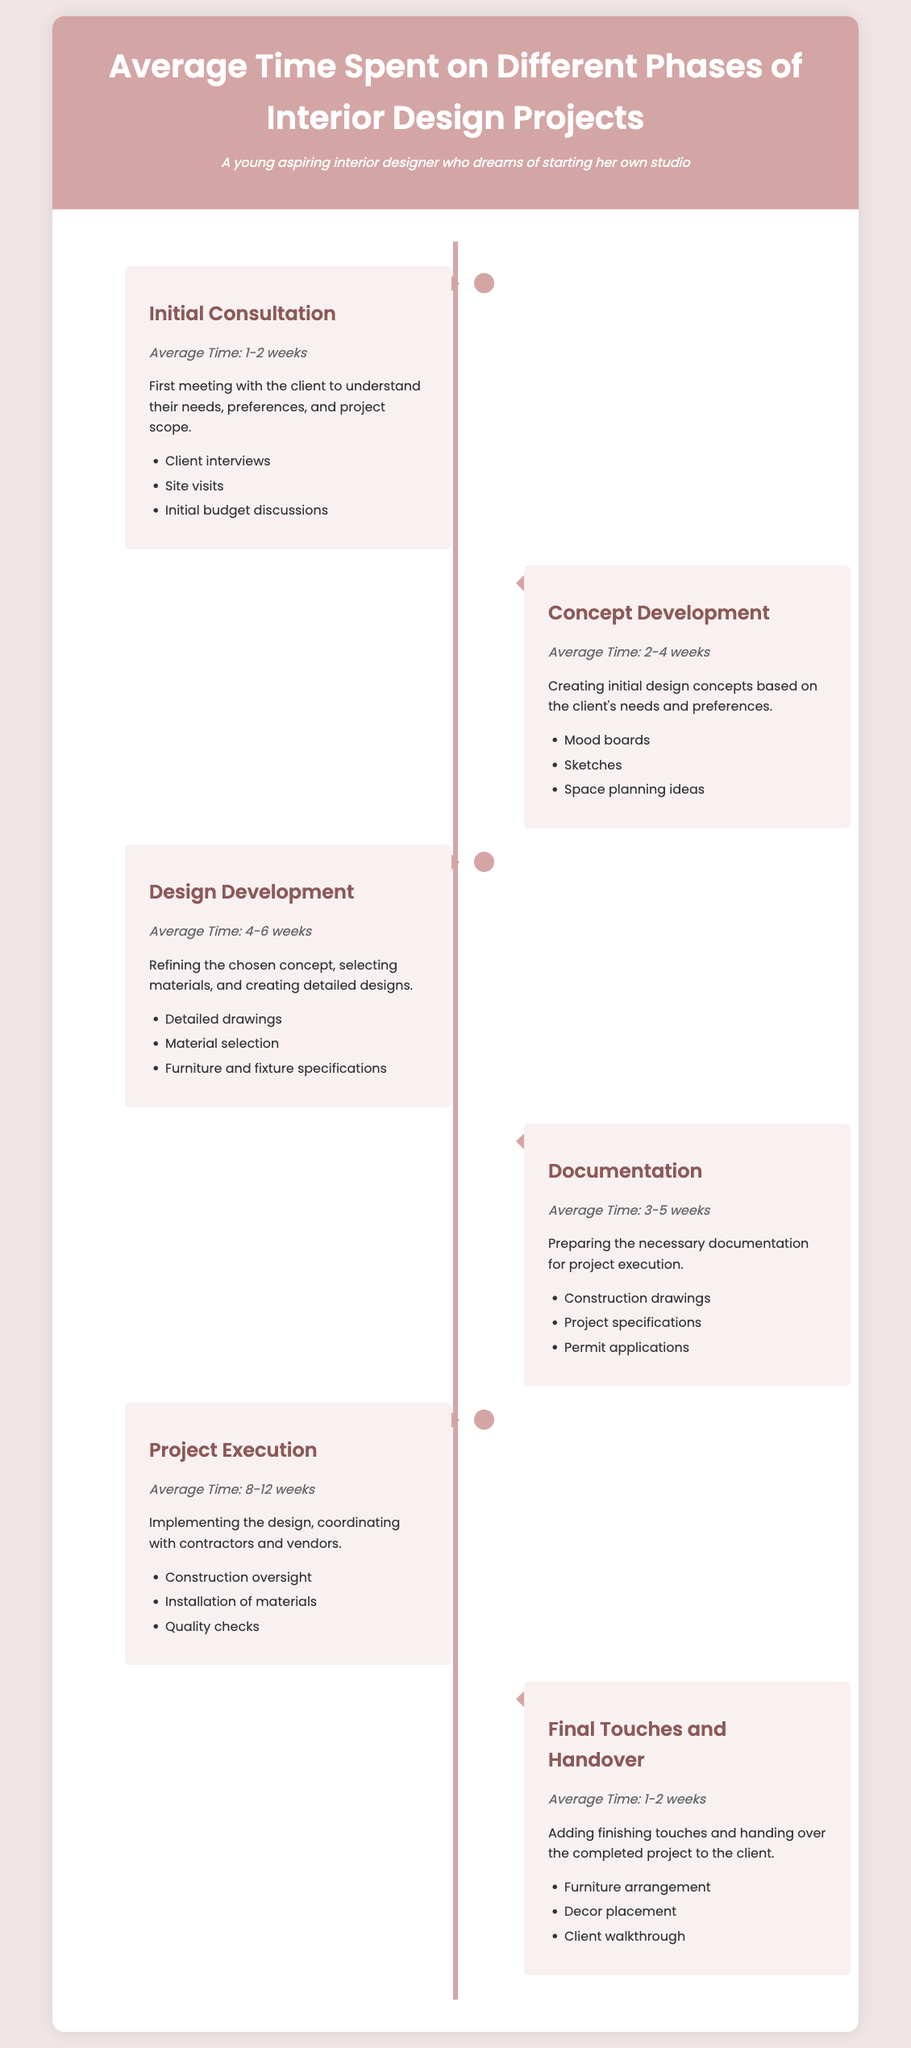What is the average time for Initial Consultation? The average time for Initial Consultation is listed in the document as 1-2 weeks.
Answer: 1-2 weeks How long does Project Execution typically take? The document states that Project Execution takes an average time of 8-12 weeks.
Answer: 8-12 weeks What phase comes after Concept Development? The phase that follows Concept Development, as shown in the document, is Design Development.
Answer: Design Development Which phase has the longest duration? The phase with the longest duration is Project Execution, as indicated in the timeline.
Answer: Project Execution What activities are included in the Documentation phase? The activities listed under the Documentation phase include construction drawings, project specifications, and permit applications.
Answer: Construction drawings, project specifications, permit applications How many weeks does Final Touches and Handover take? The document specifies that Final Touches and Handover take an average of 1-2 weeks.
Answer: 1-2 weeks What is the main task during the Design Development phase? The main task during the Design Development phase involves refining the chosen concept and selecting materials.
Answer: Refining the concept and selecting materials How many weeks does Concept Development take? Concept Development takes an average time of 2-4 weeks according to the document.
Answer: 2-4 weeks What are the activities listed for the Project Execution phase? The activities listed for the Project Execution phase include construction oversight, installation of materials, and quality checks.
Answer: Construction oversight, installation of materials, quality checks 